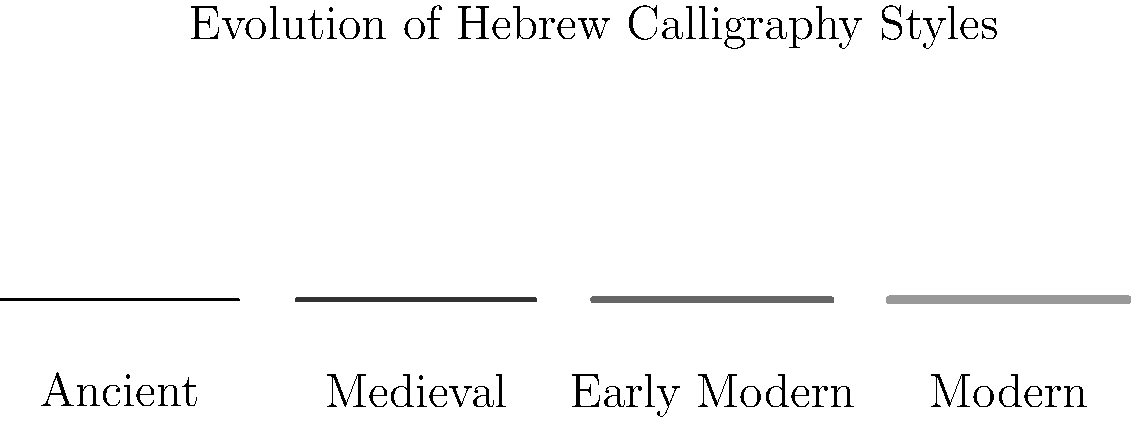Based on the timeline shown in the image, which period of Hebrew calligraphy is characterized by the thickest strokes and the darkest shade? To answer this question, we need to analyze the visual representation of Hebrew calligraphy styles across different periods:

1. The timeline shows four distinct periods: Ancient, Medieval, Early Modern, and Modern.
2. Each period is represented by a horizontal line with varying thickness and shade.
3. Moving from left to right (Ancient to Modern):
   a. The Ancient period has the thinnest line and lightest shade.
   b. The Medieval period has a slightly thicker line and darker shade.
   c. The Early Modern period continues this trend with an even thicker line and darker shade.
   d. The Modern period has the thickest line and darkest shade.

4. The question asks for the period with the thickest strokes and darkest shade.
5. Comparing all four periods, we can clearly see that the Modern period's representation has both the thickest line and the darkest shade.

This evolution in style likely reflects changes in writing tools, materials, and aesthetic preferences over time. As a rabbi emphasizing the importance of understanding historical practices in modern contexts, it's crucial to recognize how these calligraphic changes might influence our interpretation and appreciation of religious texts from different eras.
Answer: Modern 